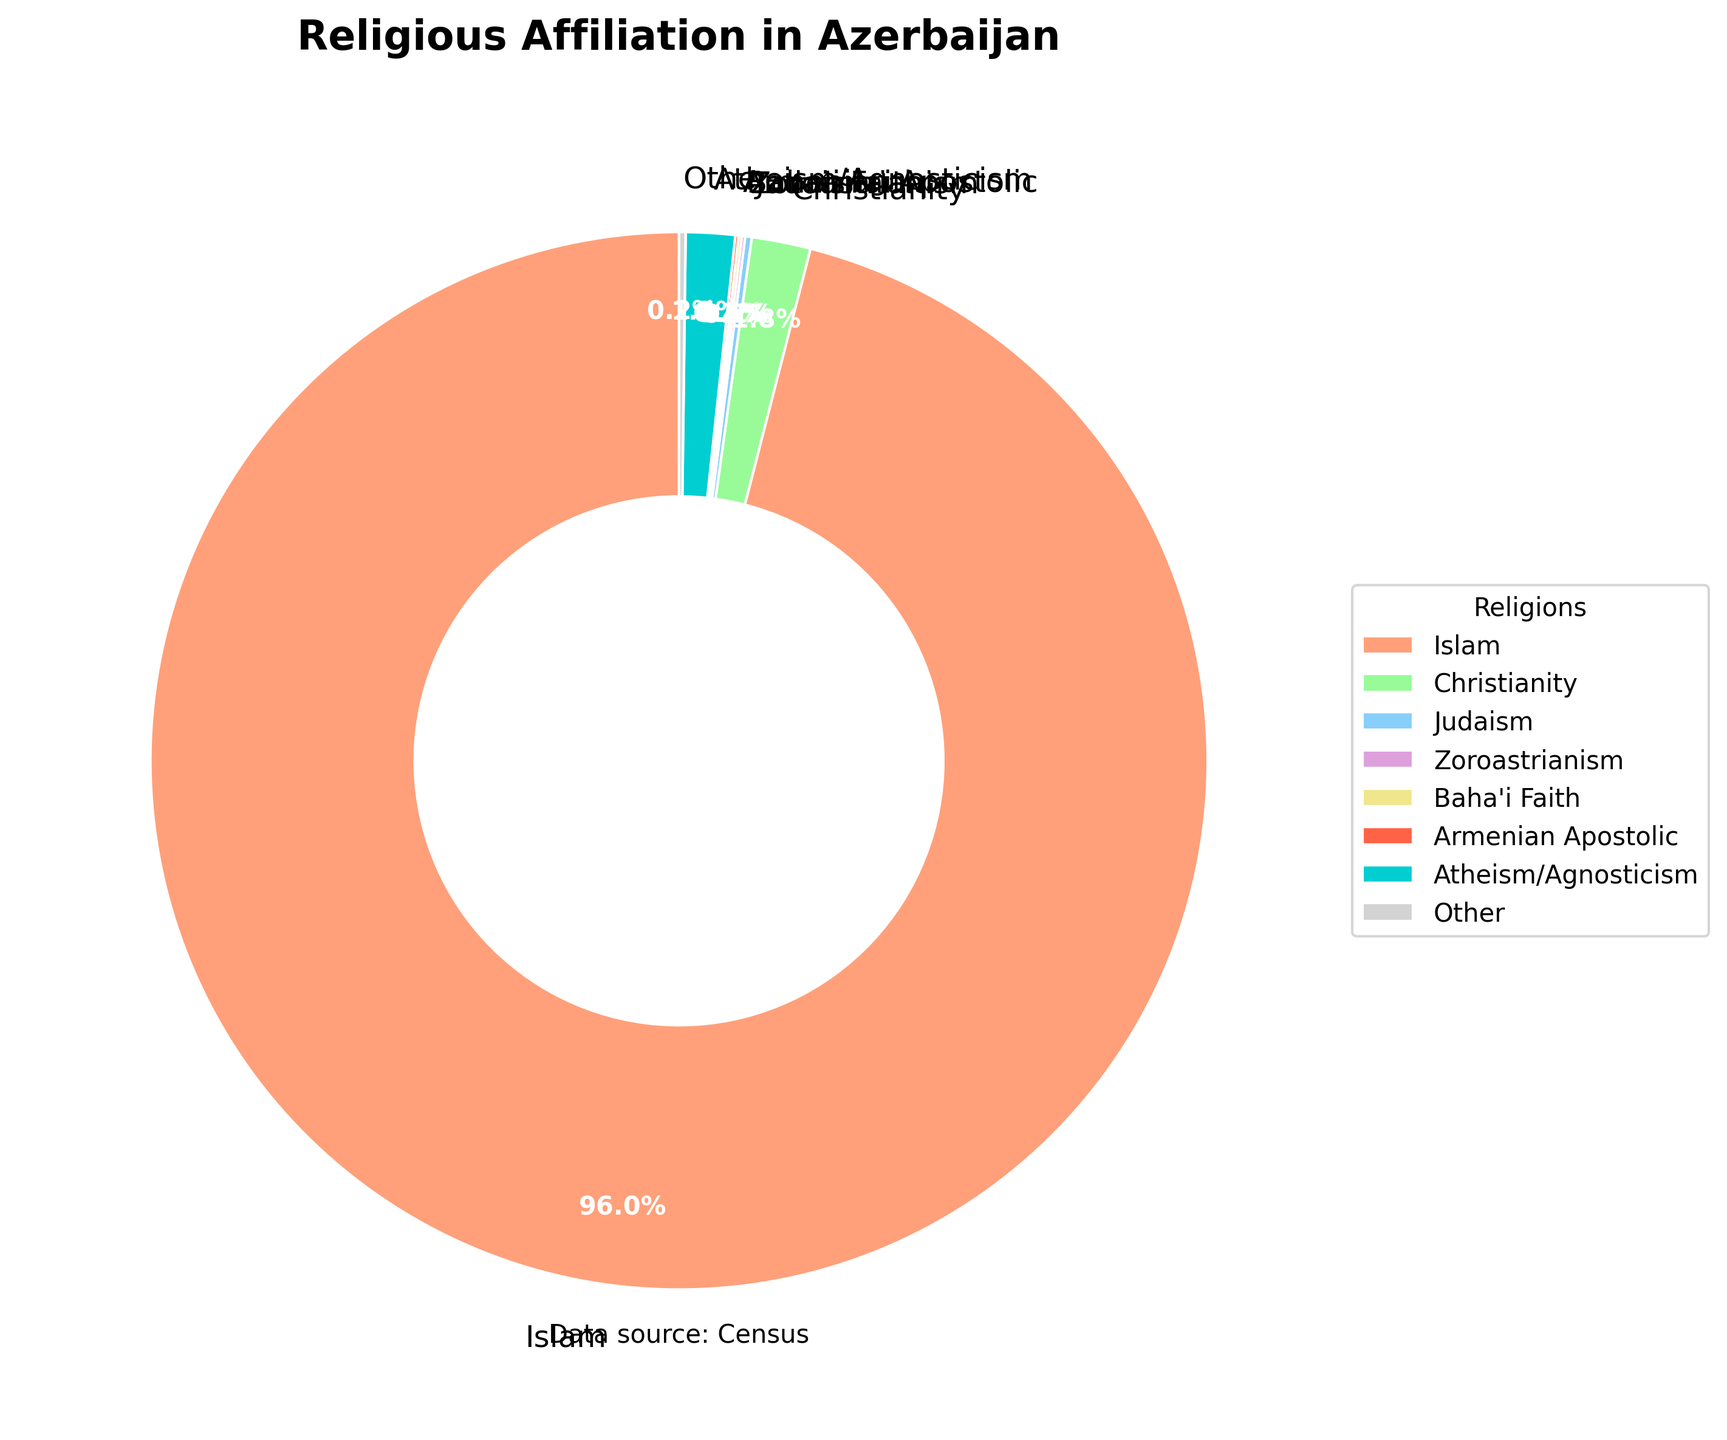Which religion has the highest percentage in Azerbaijan? The largest segment of the pie chart is labeled "Islam" with a percentage of 96.0%, indicating that Islam has the highest percentage of adherence.
Answer: Islam What is the combined percentage of Christians and Jews in Azerbaijan? The pie chart shows Christianity at 1.8% and Judaism at 0.2%. Adding these two percentages together: 1.8% + 0.2% = 2.0%.
Answer: 2.0% Is the percentage of Atheism/Agnosticism higher than the combined percentage of other minor religions (Zoroastrianism, Baha'i Faith, Armenian Apostolic, and Other)? The percentage for Atheism/Agnosticism is 1.5%. The combined percentage of Zoroastrianism (0.1%), Baha'i Faith (0.1%), Armenian Apostolic (0.1%), and Other (0.2%) is 0.1% + 0.1% + 0.1% + 0.2% = 0.5%, which is less than 1.5%.
Answer: Yes What is the total percentage of religious affiliations grouped as "Other"? The pie chart lists "Other" as 0.2%. This is already explicitly given on the chart.
Answer: 0.2% Which is larger: the percentage of Christians or the percentage of those who identify as Atheist/Agnostic? According to the pie chart, Christianity is at 1.8% and Atheism/Agnosticism is at 1.5%. Therefore, Christianity has a higher percentage.
Answer: Christianity What is the difference in percentage between the second highest and the third highest religious groups? The second highest is Christianity at 1.8%, and the third highest is Atheism/Agnosticism at 1.5%. The difference is 1.8% - 1.5% = 0.3%.
Answer: 0.3% What portion of the pie chart is colored in blue? The color blue is used for Judaism, which has a percentage of 0.2%.
Answer: 0.2% How does the percentage of the Baha'i Faith compare to the Armenian Apostolic Church? The pie chart shows the Baha'i Faith at 0.1% and the Armenian Apostolic Church also at 0.1%. They are equal in percentage.
Answer: Equal What is the percentage of non-Islamic religions combined? The non-Islamic religions are Christianity (1.8%), Judaism (0.2%), Zoroastrianism (0.1%), Baha'i Faith (0.1%), Armenian Apostolic (0.1%), Atheism/Agnosticism (1.5%), and Other (0.2%). Adding these together: 1.8% + 0.2% + 0.1% + 0.1% + 0.1% + 1.5% + 0.2% = 4.0%.
Answer: 4.0% Which segment of the pie chart is labeled with "orange"? The orange segment corresponds to Islam, which is the largest segment with 96.0%.
Answer: Islam 